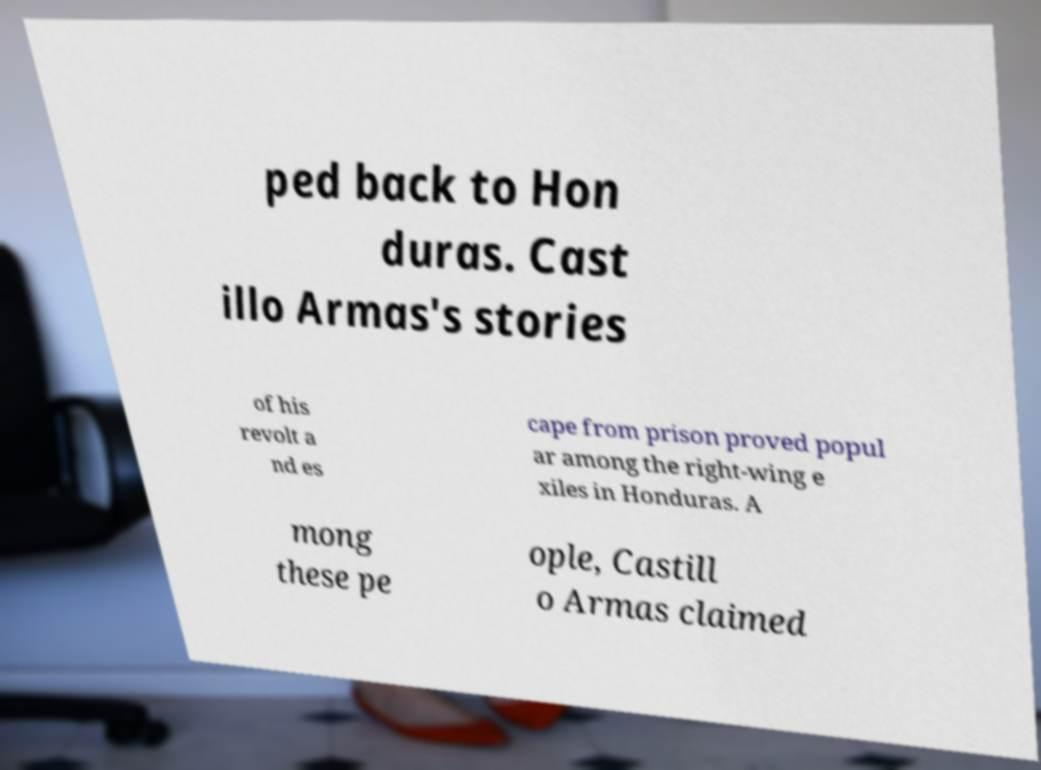Could you extract and type out the text from this image? ped back to Hon duras. Cast illo Armas's stories of his revolt a nd es cape from prison proved popul ar among the right-wing e xiles in Honduras. A mong these pe ople, Castill o Armas claimed 